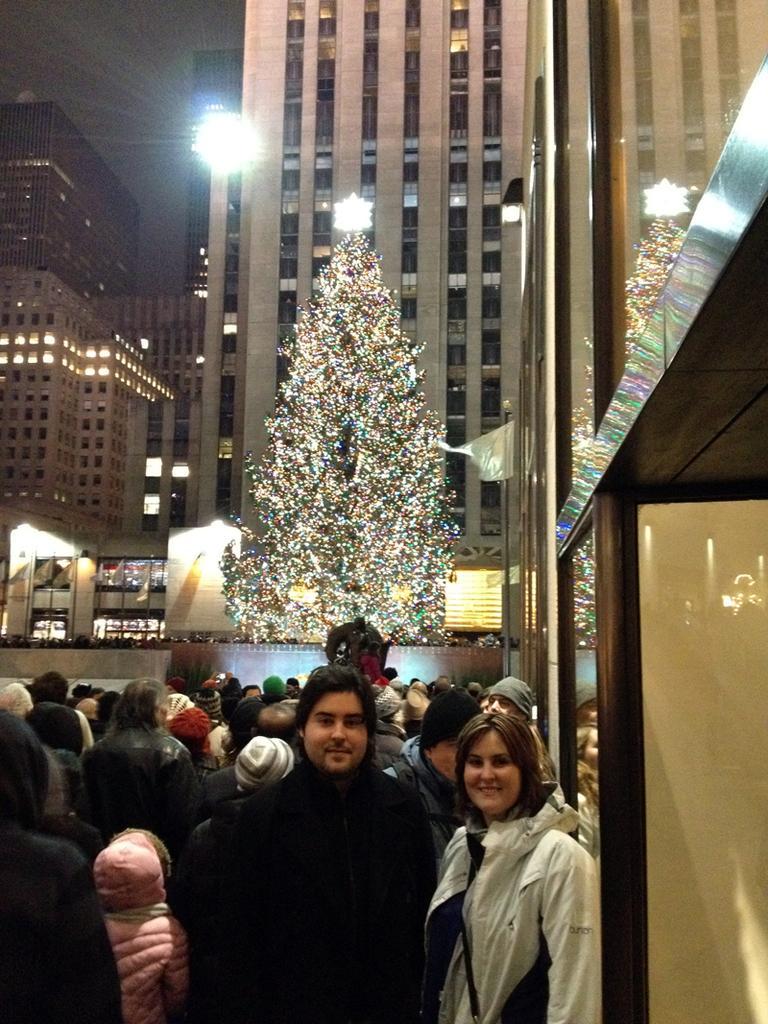How would you summarize this image in a sentence or two? In this image we can see a few people, in front of them there is a big Christmas tree, there are some lights, some buildings, also we can see the sky. 